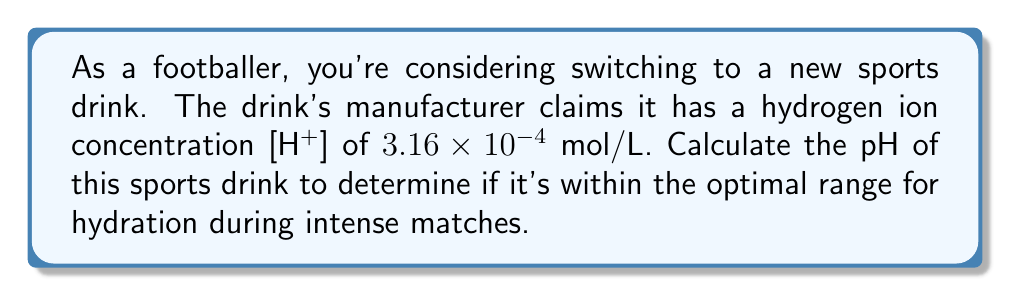Can you solve this math problem? To solve this problem, we'll use the logarithmic function for pH:

1) The pH formula is:
   $$ pH = -\log_{10}[H^+] $$

2) We're given [H+] = $3.16 \times 10^{-4}$ mol/L

3) Substituting this into the pH formula:
   $$ pH = -\log_{10}(3.16 \times 10^{-4}) $$

4) Using the properties of logarithms, we can split this:
   $$ pH = -(\log_{10}(3.16) + \log_{10}(10^{-4})) $$

5) Simplify:
   $$ pH = -(\log_{10}(3.16) - 4) $$

6) $\log_{10}(3.16)$ is approximately 0.4997

7) Therefore:
   $$ pH = -(0.4997 - 4) = 3.5003 $$

8) Rounding to two decimal places:
   $$ pH \approx 3.50 $$
Answer: 3.50 